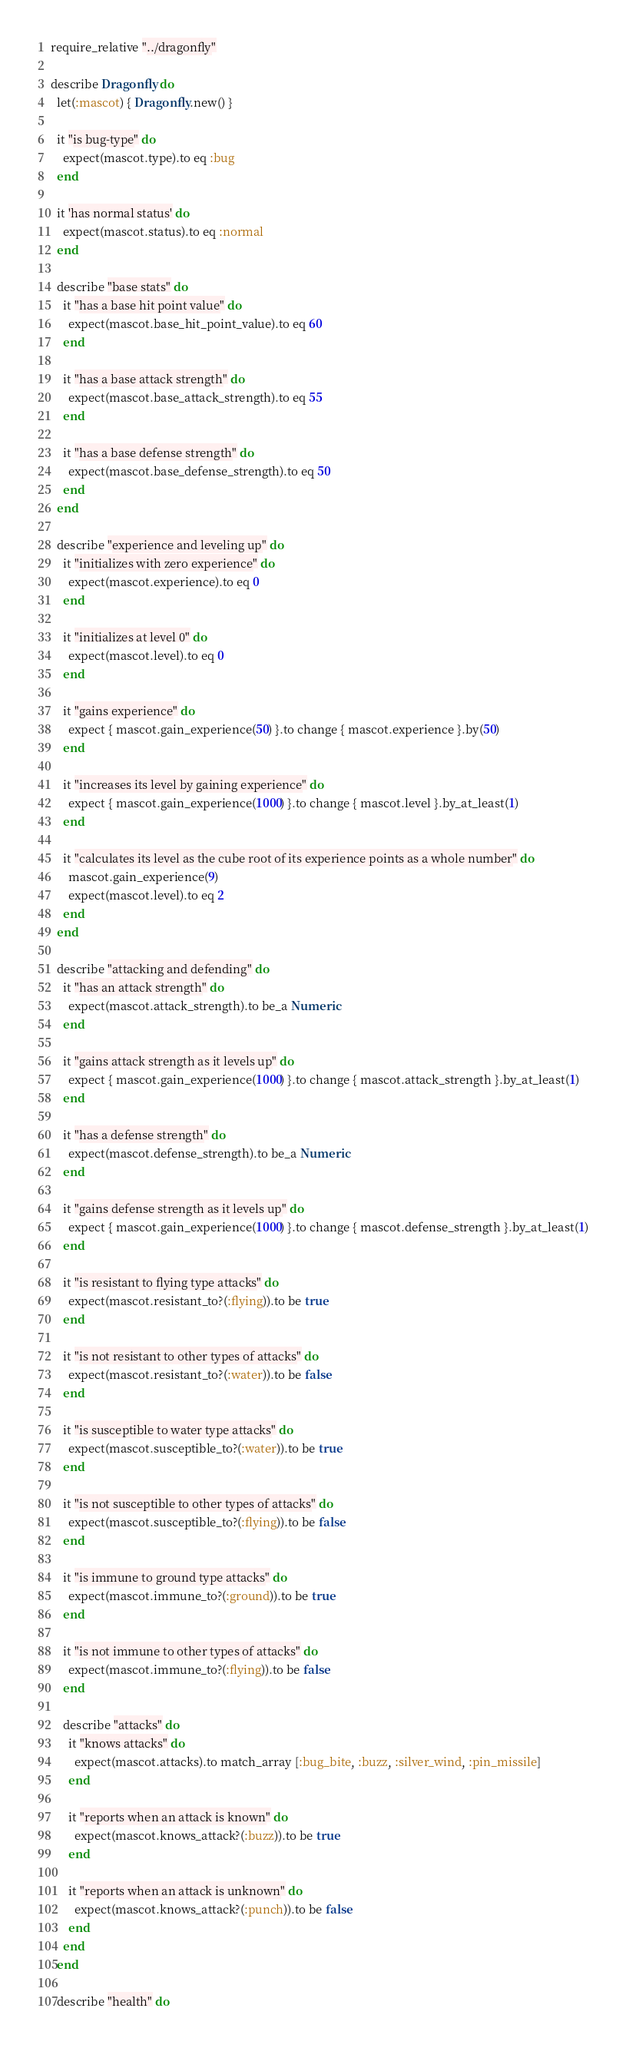<code> <loc_0><loc_0><loc_500><loc_500><_Ruby_>require_relative "../dragonfly"

describe Dragonfly do
  let(:mascot) { Dragonfly.new() }

  it "is bug-type" do
    expect(mascot.type).to eq :bug
  end

  it 'has normal status' do
    expect(mascot.status).to eq :normal
  end

  describe "base stats" do
    it "has a base hit point value" do
      expect(mascot.base_hit_point_value).to eq 60
    end

    it "has a base attack strength" do
      expect(mascot.base_attack_strength).to eq 55
    end

    it "has a base defense strength" do
      expect(mascot.base_defense_strength).to eq 50
    end
  end

  describe "experience and leveling up" do
    it "initializes with zero experience" do
      expect(mascot.experience).to eq 0
    end

    it "initializes at level 0" do
      expect(mascot.level).to eq 0
    end

    it "gains experience" do
      expect { mascot.gain_experience(50) }.to change { mascot.experience }.by(50)
    end

    it "increases its level by gaining experience" do
      expect { mascot.gain_experience(1000) }.to change { mascot.level }.by_at_least(1)
    end

    it "calculates its level as the cube root of its experience points as a whole number" do
      mascot.gain_experience(9)
      expect(mascot.level).to eq 2
    end
  end

  describe "attacking and defending" do
    it "has an attack strength" do
      expect(mascot.attack_strength).to be_a Numeric
    end

    it "gains attack strength as it levels up" do
      expect { mascot.gain_experience(1000) }.to change { mascot.attack_strength }.by_at_least(1)
    end

    it "has a defense strength" do
      expect(mascot.defense_strength).to be_a Numeric
    end

    it "gains defense strength as it levels up" do
      expect { mascot.gain_experience(1000) }.to change { mascot.defense_strength }.by_at_least(1)
    end

    it "is resistant to flying type attacks" do
      expect(mascot.resistant_to?(:flying)).to be true
    end

    it "is not resistant to other types of attacks" do
      expect(mascot.resistant_to?(:water)).to be false
    end

    it "is susceptible to water type attacks" do
      expect(mascot.susceptible_to?(:water)).to be true
    end

    it "is not susceptible to other types of attacks" do
      expect(mascot.susceptible_to?(:flying)).to be false
    end

    it "is immune to ground type attacks" do
      expect(mascot.immune_to?(:ground)).to be true
    end

    it "is not immune to other types of attacks" do
      expect(mascot.immune_to?(:flying)).to be false
    end

    describe "attacks" do
      it "knows attacks" do
        expect(mascot.attacks).to match_array [:bug_bite, :buzz, :silver_wind, :pin_missile]
      end

      it "reports when an attack is known" do
        expect(mascot.knows_attack?(:buzz)).to be true
      end

      it "reports when an attack is unknown" do
        expect(mascot.knows_attack?(:punch)).to be false
      end
    end
  end

  describe "health" do</code> 